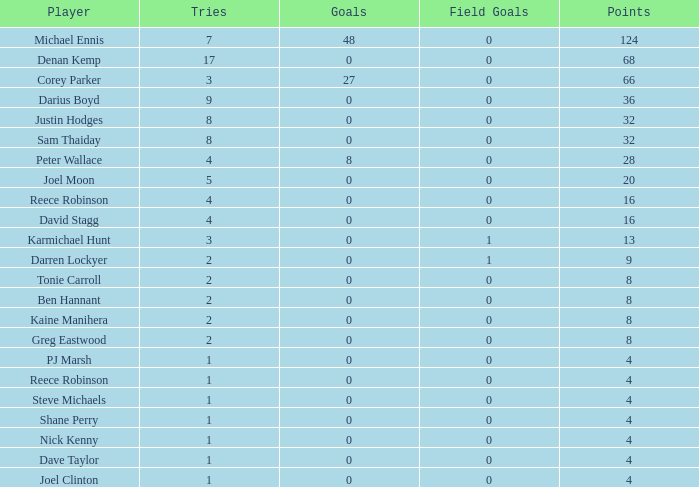How many goals does dave taylor have, considering he has over 1 try? None. 